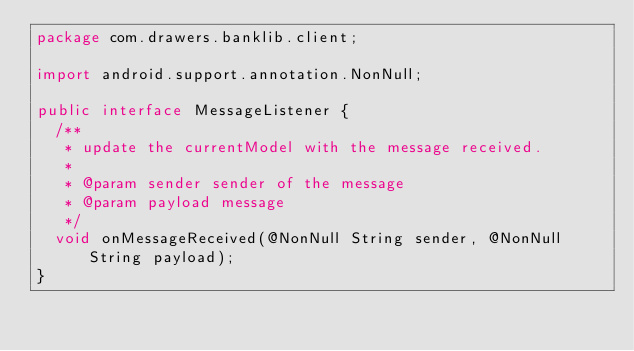Convert code to text. <code><loc_0><loc_0><loc_500><loc_500><_Java_>package com.drawers.banklib.client;

import android.support.annotation.NonNull;

public interface MessageListener {
  /**
   * update the currentModel with the message received.
   *
   * @param sender sender of the message
   * @param payload message
   */
  void onMessageReceived(@NonNull String sender, @NonNull String payload);
}
</code> 